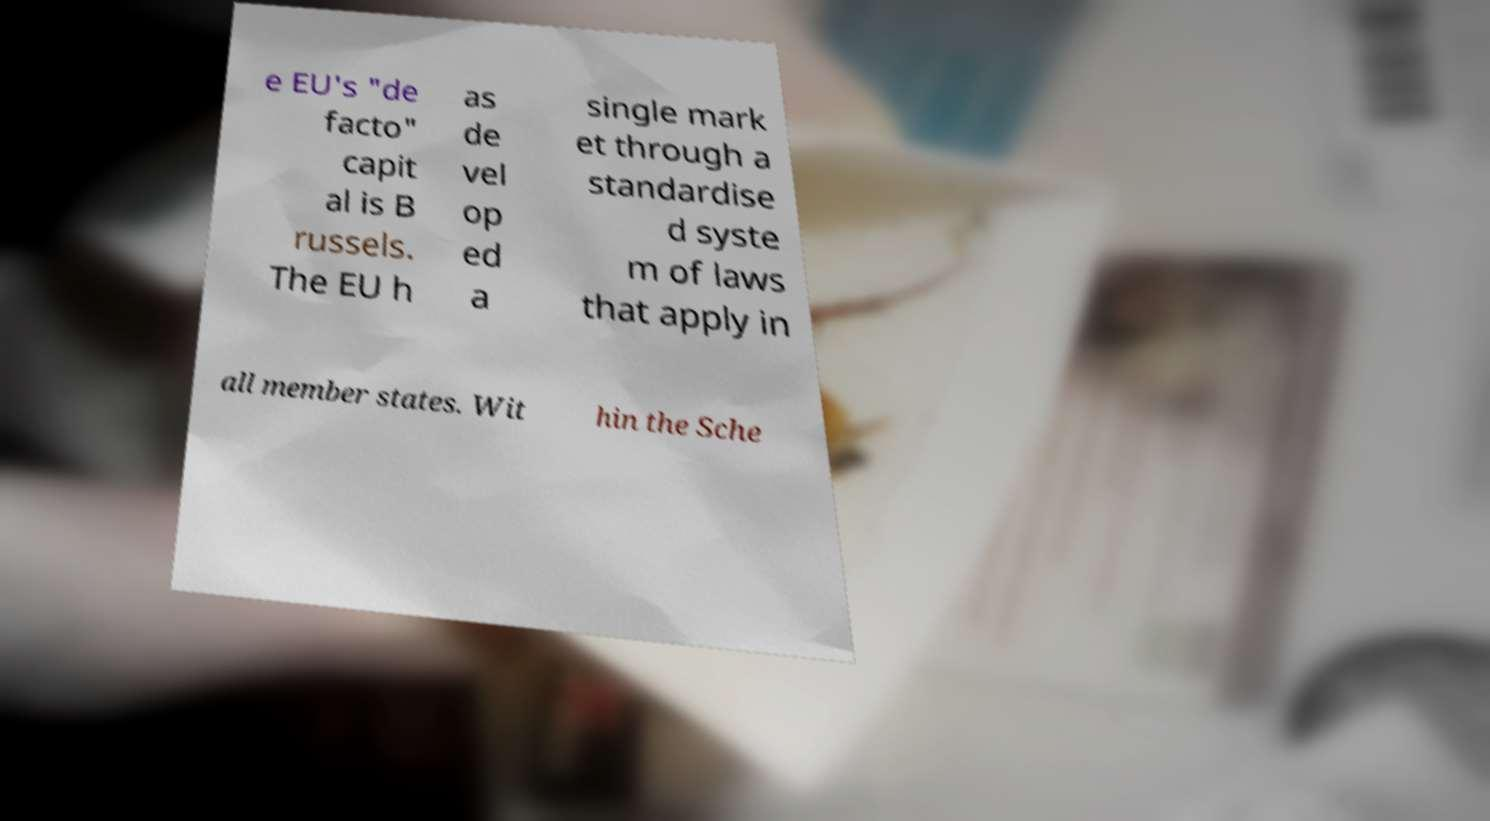Can you accurately transcribe the text from the provided image for me? e EU's "de facto" capit al is B russels. The EU h as de vel op ed a single mark et through a standardise d syste m of laws that apply in all member states. Wit hin the Sche 